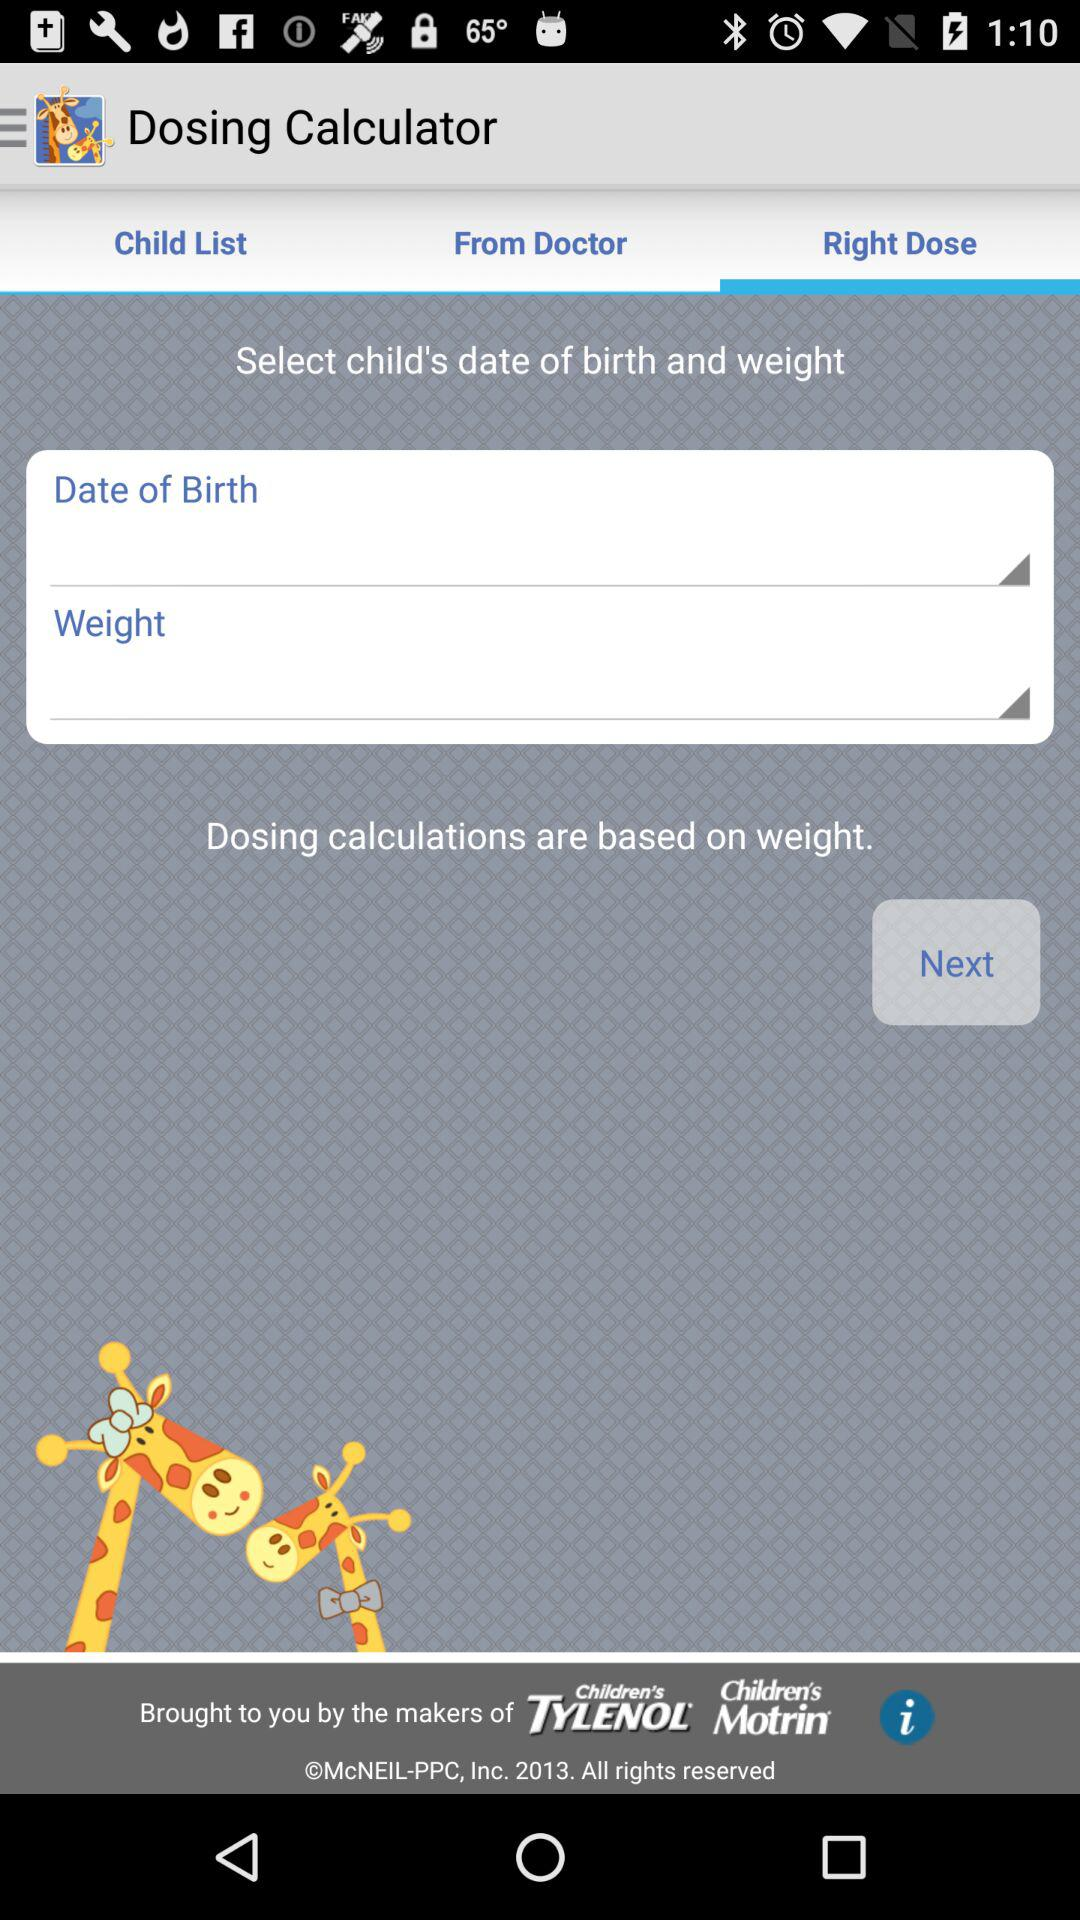How many text inputs are on the screen?
Answer the question using a single word or phrase. 2 